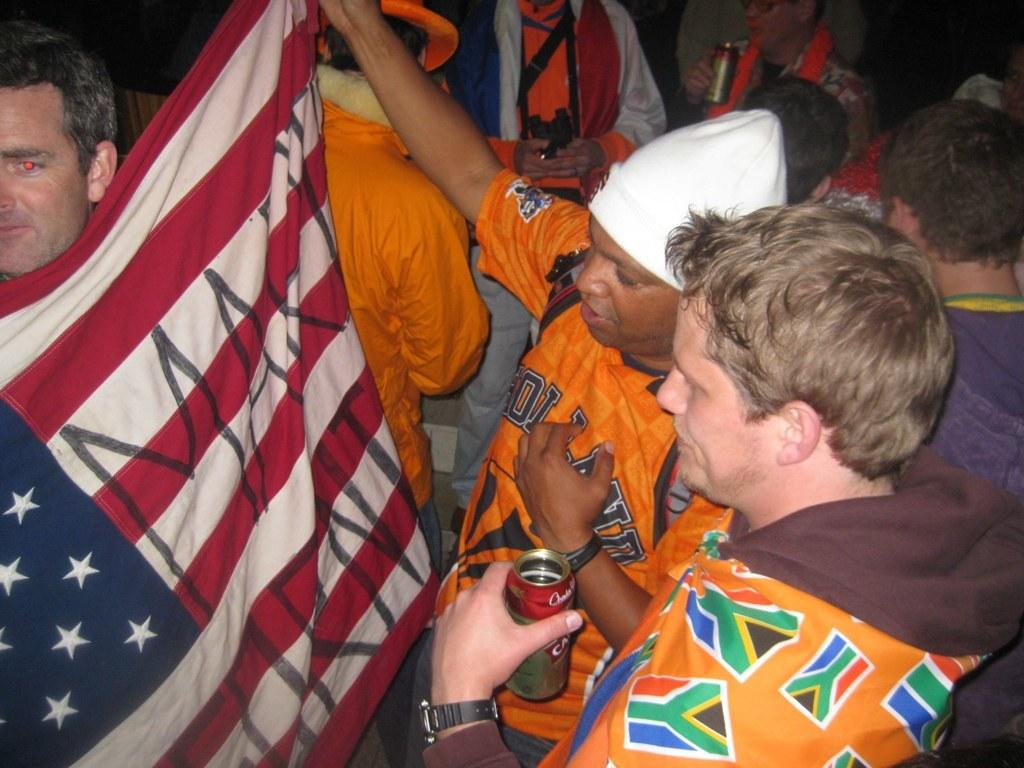What are the people in the image doing with their hands? The people in the image are holding objects in their hands. Can you describe the specific object being held by one of the people? Yes, one person is holding a flag. How would you describe the overall appearance of the background in the image? The background of the image has a dark view. Is there a boat visible in the image? No, there is no boat present in the image. Can you tell me who the person holding the flag is related to? The provided facts do not give any information about the person's relationship to others, so we cannot determine if they are related to an uncle or anyone else. 